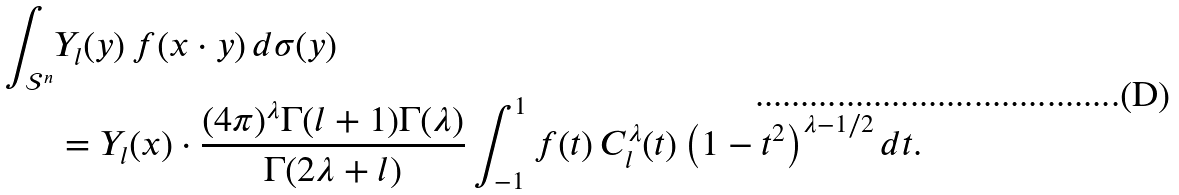<formula> <loc_0><loc_0><loc_500><loc_500>\int _ { \mathcal { S } ^ { n } } & Y _ { l } ( y ) \, f ( x \cdot y ) \, d \sigma ( y ) \\ & = Y _ { l } ( x ) \cdot \frac { ( 4 \pi ) ^ { \lambda } \Gamma ( l + 1 ) \Gamma ( \lambda ) } { \Gamma ( 2 \lambda + l ) } \int _ { - 1 } ^ { 1 } f ( t ) \, C _ { l } ^ { \lambda } ( t ) \left ( 1 - t ^ { 2 } \right ) ^ { \lambda - 1 / 2 } d t .</formula> 